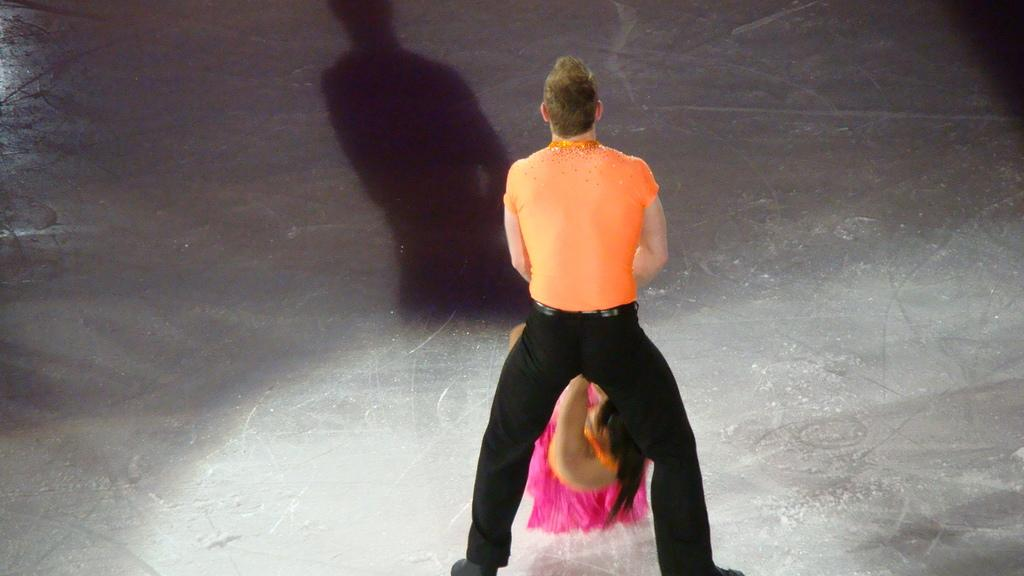What is the main subject of the image? There is a man in the image. What is the man doing in the image? The man is holding a lady. What is the surface beneath the man and lady? There is a floor visible in the image. What type of bun is the man holding in the image? There is no bun present in the image; the man is holding a lady. Can you see a car in the image? There is no car present in the image. 